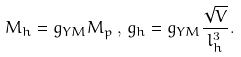Convert formula to latex. <formula><loc_0><loc_0><loc_500><loc_500>M _ { h } = g _ { Y M } M _ { p } \, , \, g _ { h } = g _ { Y M } \frac { \sqrt { V } } { l _ { h } ^ { 3 } } .</formula> 